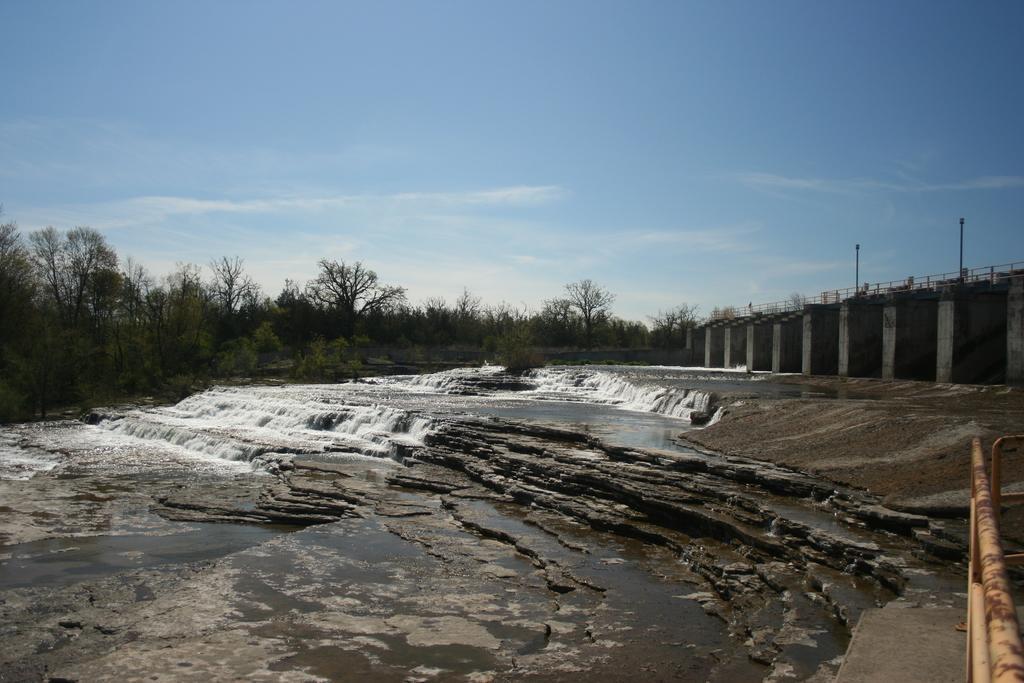Could you give a brief overview of what you see in this image? In the center of the image there is water flowing on the stones. In the background of the image there are trees. To the right side of the image there is fencing. There is a rod. 